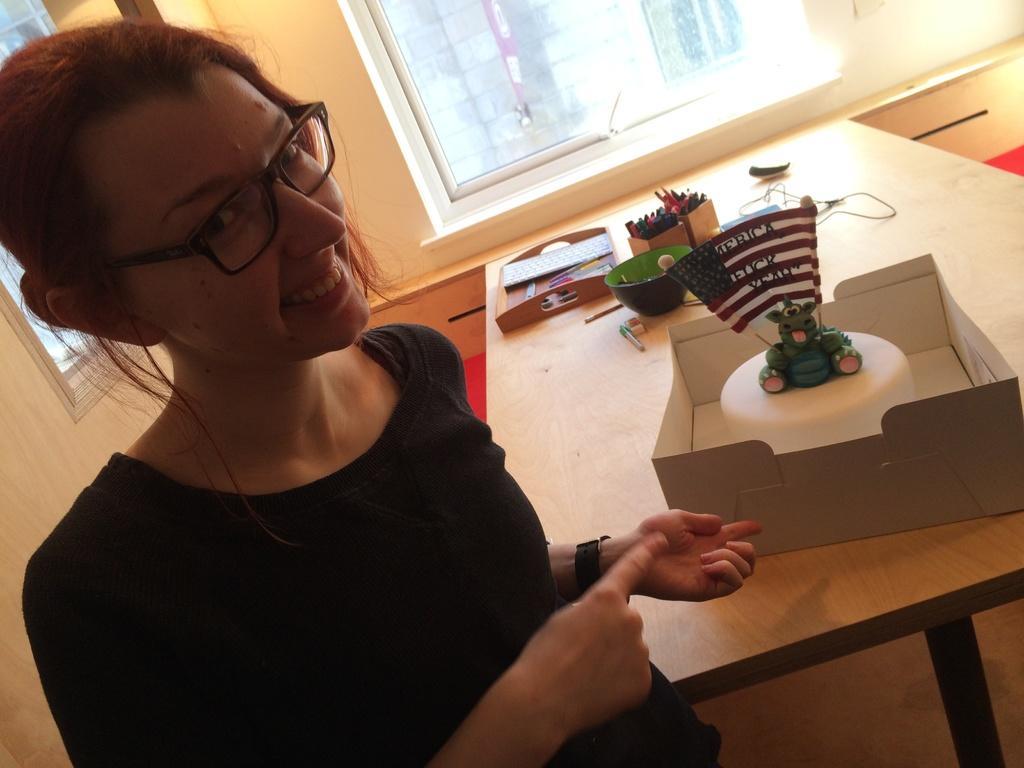In one or two sentences, can you explain what this image depicts? In this image I can see a woman is smiling and wearing a black dress. I can also see there is a table with a cake and other objects on it. I can also see there is a window. 